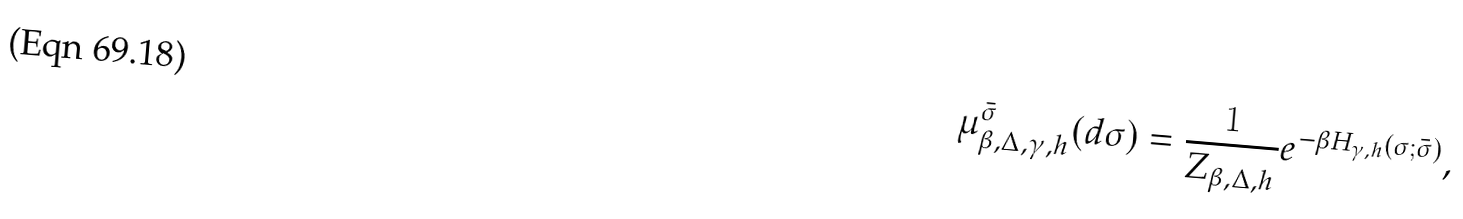Convert formula to latex. <formula><loc_0><loc_0><loc_500><loc_500>\mu ^ { \bar { \sigma } } _ { \beta , \Delta , \gamma , h } ( d \sigma ) = \frac { 1 } { Z _ { \beta , \Delta , h } } e ^ { - \beta H _ { \gamma , h } ( \sigma ; \bar { \sigma } ) } ,</formula> 